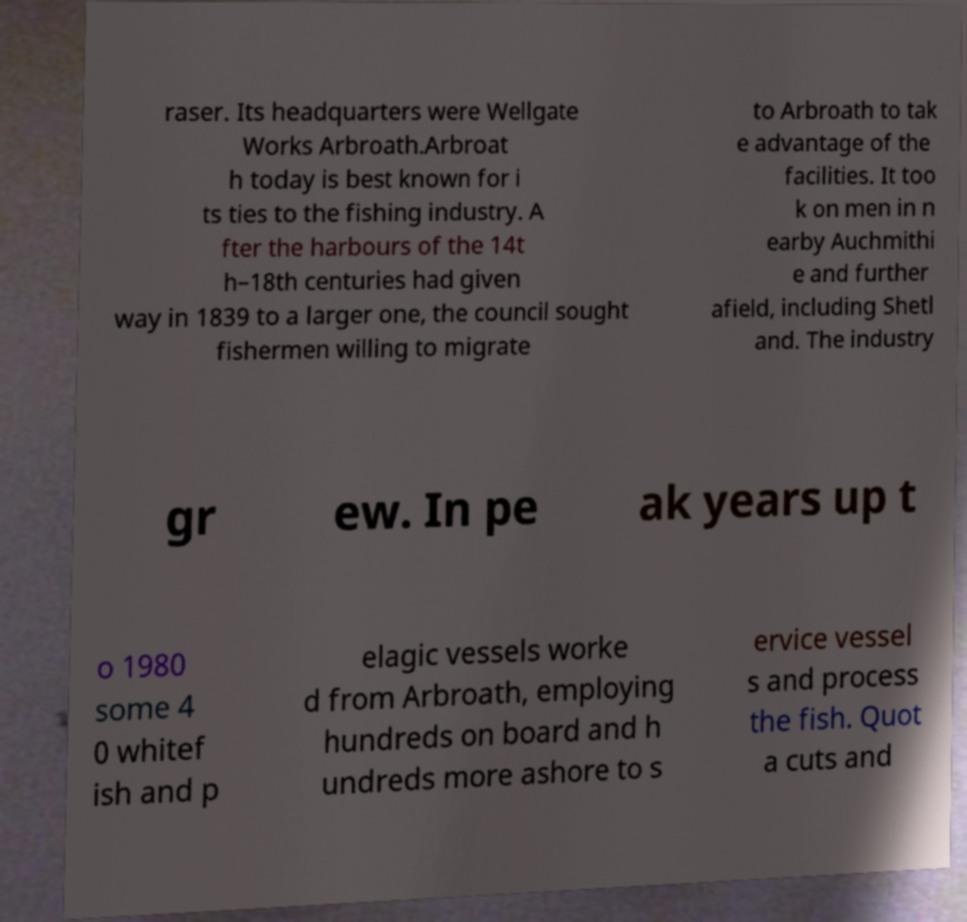Could you extract and type out the text from this image? raser. Its headquarters were Wellgate Works Arbroath.Arbroat h today is best known for i ts ties to the fishing industry. A fter the harbours of the 14t h–18th centuries had given way in 1839 to a larger one, the council sought fishermen willing to migrate to Arbroath to tak e advantage of the facilities. It too k on men in n earby Auchmithi e and further afield, including Shetl and. The industry gr ew. In pe ak years up t o 1980 some 4 0 whitef ish and p elagic vessels worke d from Arbroath, employing hundreds on board and h undreds more ashore to s ervice vessel s and process the fish. Quot a cuts and 